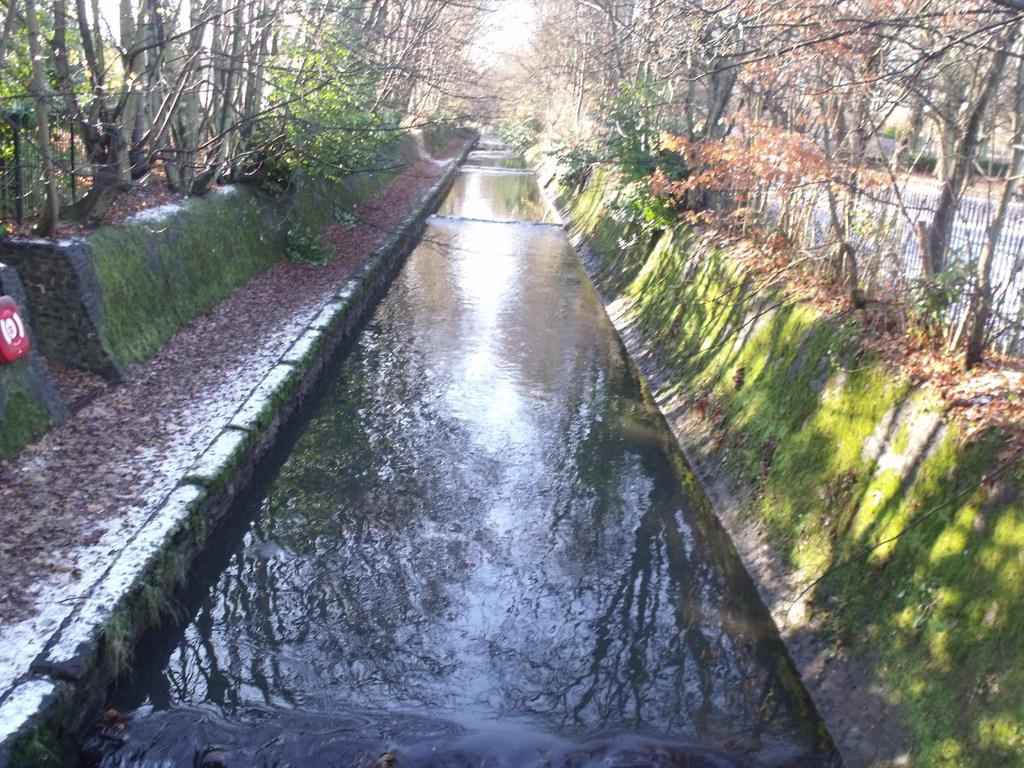What is located in the middle of the image? There is a canal in the middle of the image. What can be seen in the background of the image? There are trees in the background of the image. Where is the wren perched in the image? There is no wren present in the image. What type of animal can be seen at the zoo in the image? There is no zoo or any animals present in the image; it features a canal and trees. 